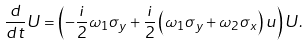Convert formula to latex. <formula><loc_0><loc_0><loc_500><loc_500>\frac { d } { d t } U = \left ( - \frac { i } { 2 } \omega _ { 1 } \sigma _ { y } + \frac { i } { 2 } \left ( \omega _ { 1 } \sigma _ { y } + \omega _ { 2 } \sigma _ { x } \right ) u \right ) U .</formula> 